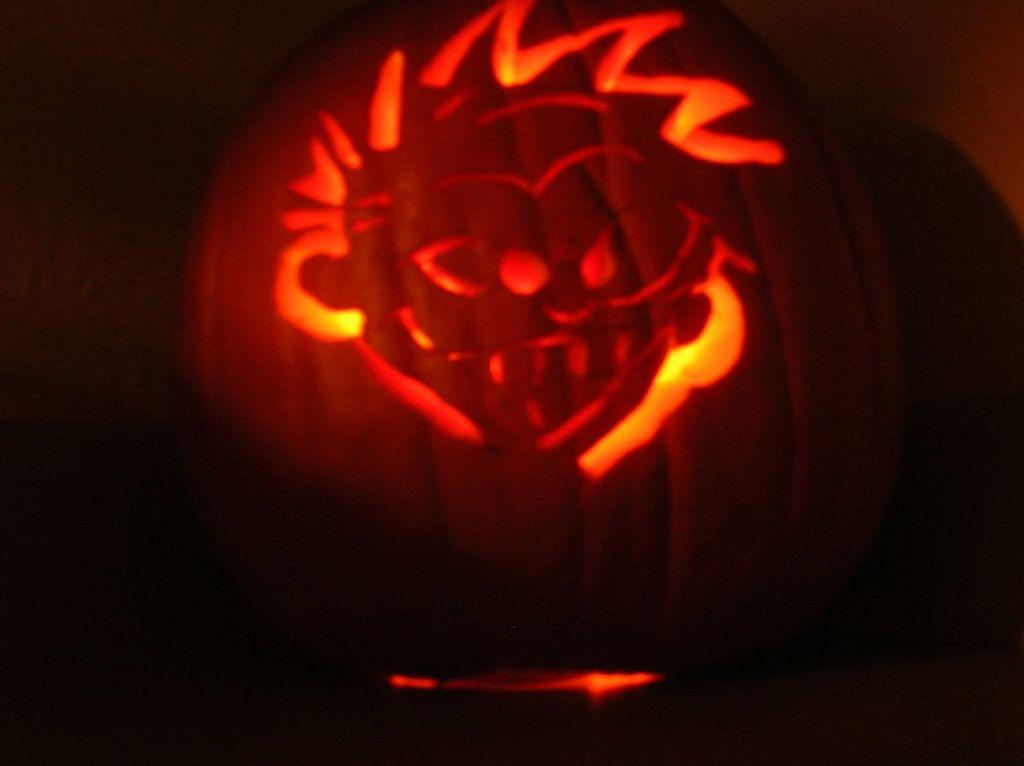What is the main subject of the image? The main subject of the image is light in the middle of the image. What color is the background of the image? The background of the image is black. What type of apparatus is being sold in the shop in the image? There is no shop or apparatus present in the image; it only features light in the middle of a black background. What is the daughter doing in the image? There is no daughter present in the image. 